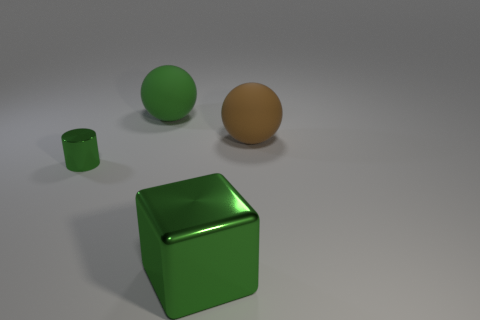The ball that is the same color as the big cube is what size?
Offer a terse response. Large. There is a large cube that is the same color as the cylinder; what is its material?
Your response must be concise. Metal. Is the material of the brown sphere that is in front of the big green sphere the same as the big green thing behind the shiny block?
Offer a terse response. Yes. Is the number of green objects right of the big green metallic thing greater than the number of green spheres on the left side of the tiny thing?
Give a very brief answer. No. There is a shiny thing that is the same size as the green ball; what is its shape?
Provide a succinct answer. Cube. How many things are tiny rubber cubes or green things in front of the small green object?
Ensure brevity in your answer.  1. Is the color of the big block the same as the tiny cylinder?
Provide a short and direct response. Yes. There is a tiny green metal cylinder; what number of big objects are in front of it?
Provide a succinct answer. 1. The other object that is made of the same material as the small green object is what color?
Your answer should be very brief. Green. How many rubber things are brown spheres or small purple blocks?
Offer a very short reply. 1. 